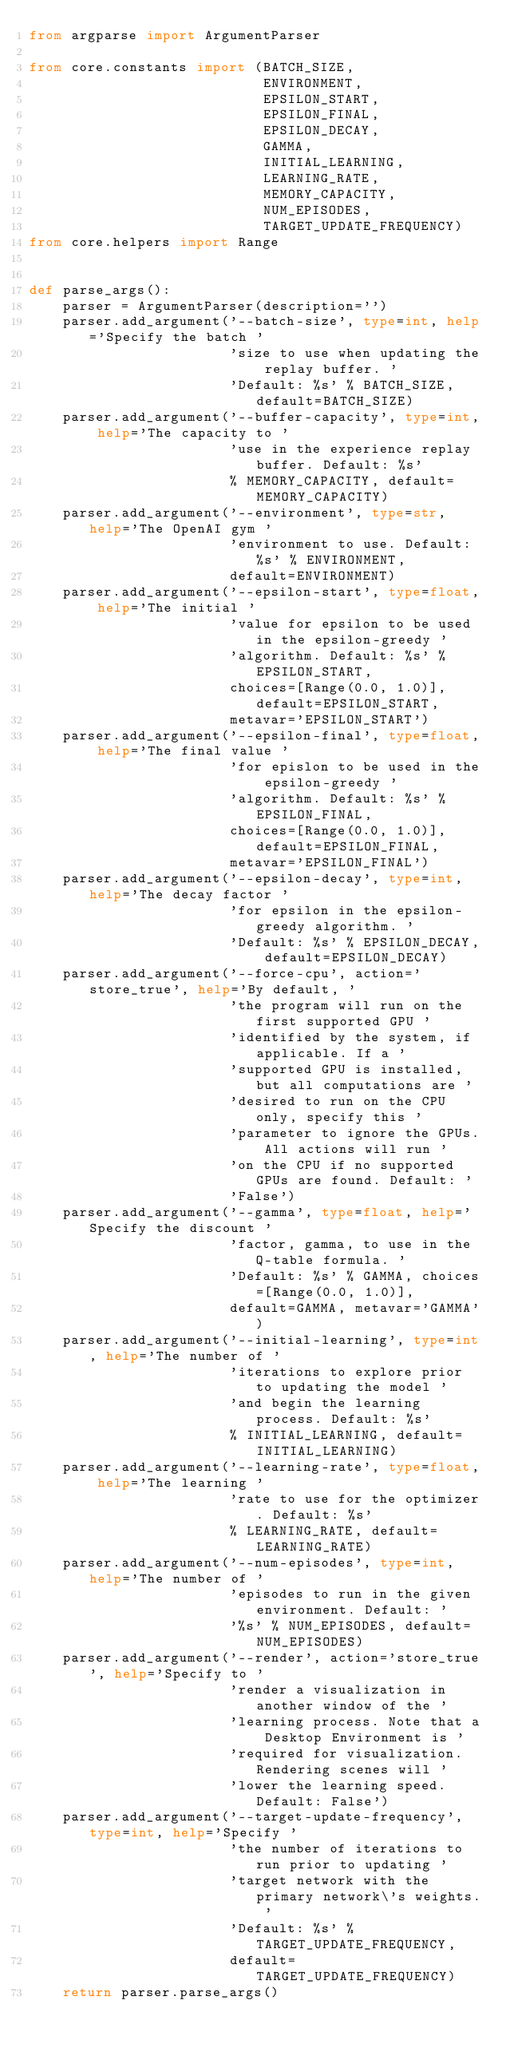Convert code to text. <code><loc_0><loc_0><loc_500><loc_500><_Python_>from argparse import ArgumentParser

from core.constants import (BATCH_SIZE,
                            ENVIRONMENT,
                            EPSILON_START,
                            EPSILON_FINAL,
                            EPSILON_DECAY,
                            GAMMA,
                            INITIAL_LEARNING,
                            LEARNING_RATE,
                            MEMORY_CAPACITY,
                            NUM_EPISODES,
                            TARGET_UPDATE_FREQUENCY)
from core.helpers import Range


def parse_args():
    parser = ArgumentParser(description='')
    parser.add_argument('--batch-size', type=int, help='Specify the batch '
                        'size to use when updating the replay buffer. '
                        'Default: %s' % BATCH_SIZE, default=BATCH_SIZE)
    parser.add_argument('--buffer-capacity', type=int, help='The capacity to '
                        'use in the experience replay buffer. Default: %s'
                        % MEMORY_CAPACITY, default=MEMORY_CAPACITY)
    parser.add_argument('--environment', type=str, help='The OpenAI gym '
                        'environment to use. Default: %s' % ENVIRONMENT,
                        default=ENVIRONMENT)
    parser.add_argument('--epsilon-start', type=float, help='The initial '
                        'value for epsilon to be used in the epsilon-greedy '
                        'algorithm. Default: %s' % EPSILON_START,
                        choices=[Range(0.0, 1.0)], default=EPSILON_START,
                        metavar='EPSILON_START')
    parser.add_argument('--epsilon-final', type=float, help='The final value '
                        'for epislon to be used in the epsilon-greedy '
                        'algorithm. Default: %s' % EPSILON_FINAL,
                        choices=[Range(0.0, 1.0)], default=EPSILON_FINAL,
                        metavar='EPSILON_FINAL')
    parser.add_argument('--epsilon-decay', type=int, help='The decay factor '
                        'for epsilon in the epsilon-greedy algorithm. '
                        'Default: %s' % EPSILON_DECAY, default=EPSILON_DECAY)
    parser.add_argument('--force-cpu', action='store_true', help='By default, '
                        'the program will run on the first supported GPU '
                        'identified by the system, if applicable. If a '
                        'supported GPU is installed, but all computations are '
                        'desired to run on the CPU only, specify this '
                        'parameter to ignore the GPUs. All actions will run '
                        'on the CPU if no supported GPUs are found. Default: '
                        'False')
    parser.add_argument('--gamma', type=float, help='Specify the discount '
                        'factor, gamma, to use in the Q-table formula. '
                        'Default: %s' % GAMMA, choices=[Range(0.0, 1.0)],
                        default=GAMMA, metavar='GAMMA')
    parser.add_argument('--initial-learning', type=int, help='The number of '
                        'iterations to explore prior to updating the model '
                        'and begin the learning process. Default: %s'
                        % INITIAL_LEARNING, default=INITIAL_LEARNING)
    parser.add_argument('--learning-rate', type=float, help='The learning '
                        'rate to use for the optimizer. Default: %s'
                        % LEARNING_RATE, default=LEARNING_RATE)
    parser.add_argument('--num-episodes', type=int, help='The number of '
                        'episodes to run in the given environment. Default: '
                        '%s' % NUM_EPISODES, default=NUM_EPISODES)
    parser.add_argument('--render', action='store_true', help='Specify to '
                        'render a visualization in another window of the '
                        'learning process. Note that a Desktop Environment is '
                        'required for visualization. Rendering scenes will '
                        'lower the learning speed. Default: False')
    parser.add_argument('--target-update-frequency', type=int, help='Specify '
                        'the number of iterations to run prior to updating '
                        'target network with the primary network\'s weights. '
                        'Default: %s' % TARGET_UPDATE_FREQUENCY,
                        default=TARGET_UPDATE_FREQUENCY)
    return parser.parse_args()
</code> 